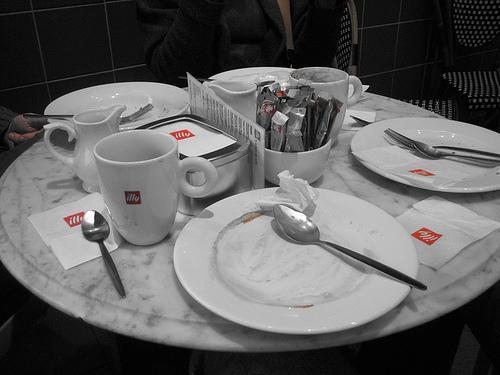How many place settings are visible?
Give a very brief answer. 4. How many cups are in the picture?
Give a very brief answer. 3. How many chairs can be seen?
Give a very brief answer. 2. How many bowls are there?
Give a very brief answer. 1. How many hot dogs will this person be eating?
Give a very brief answer. 0. 